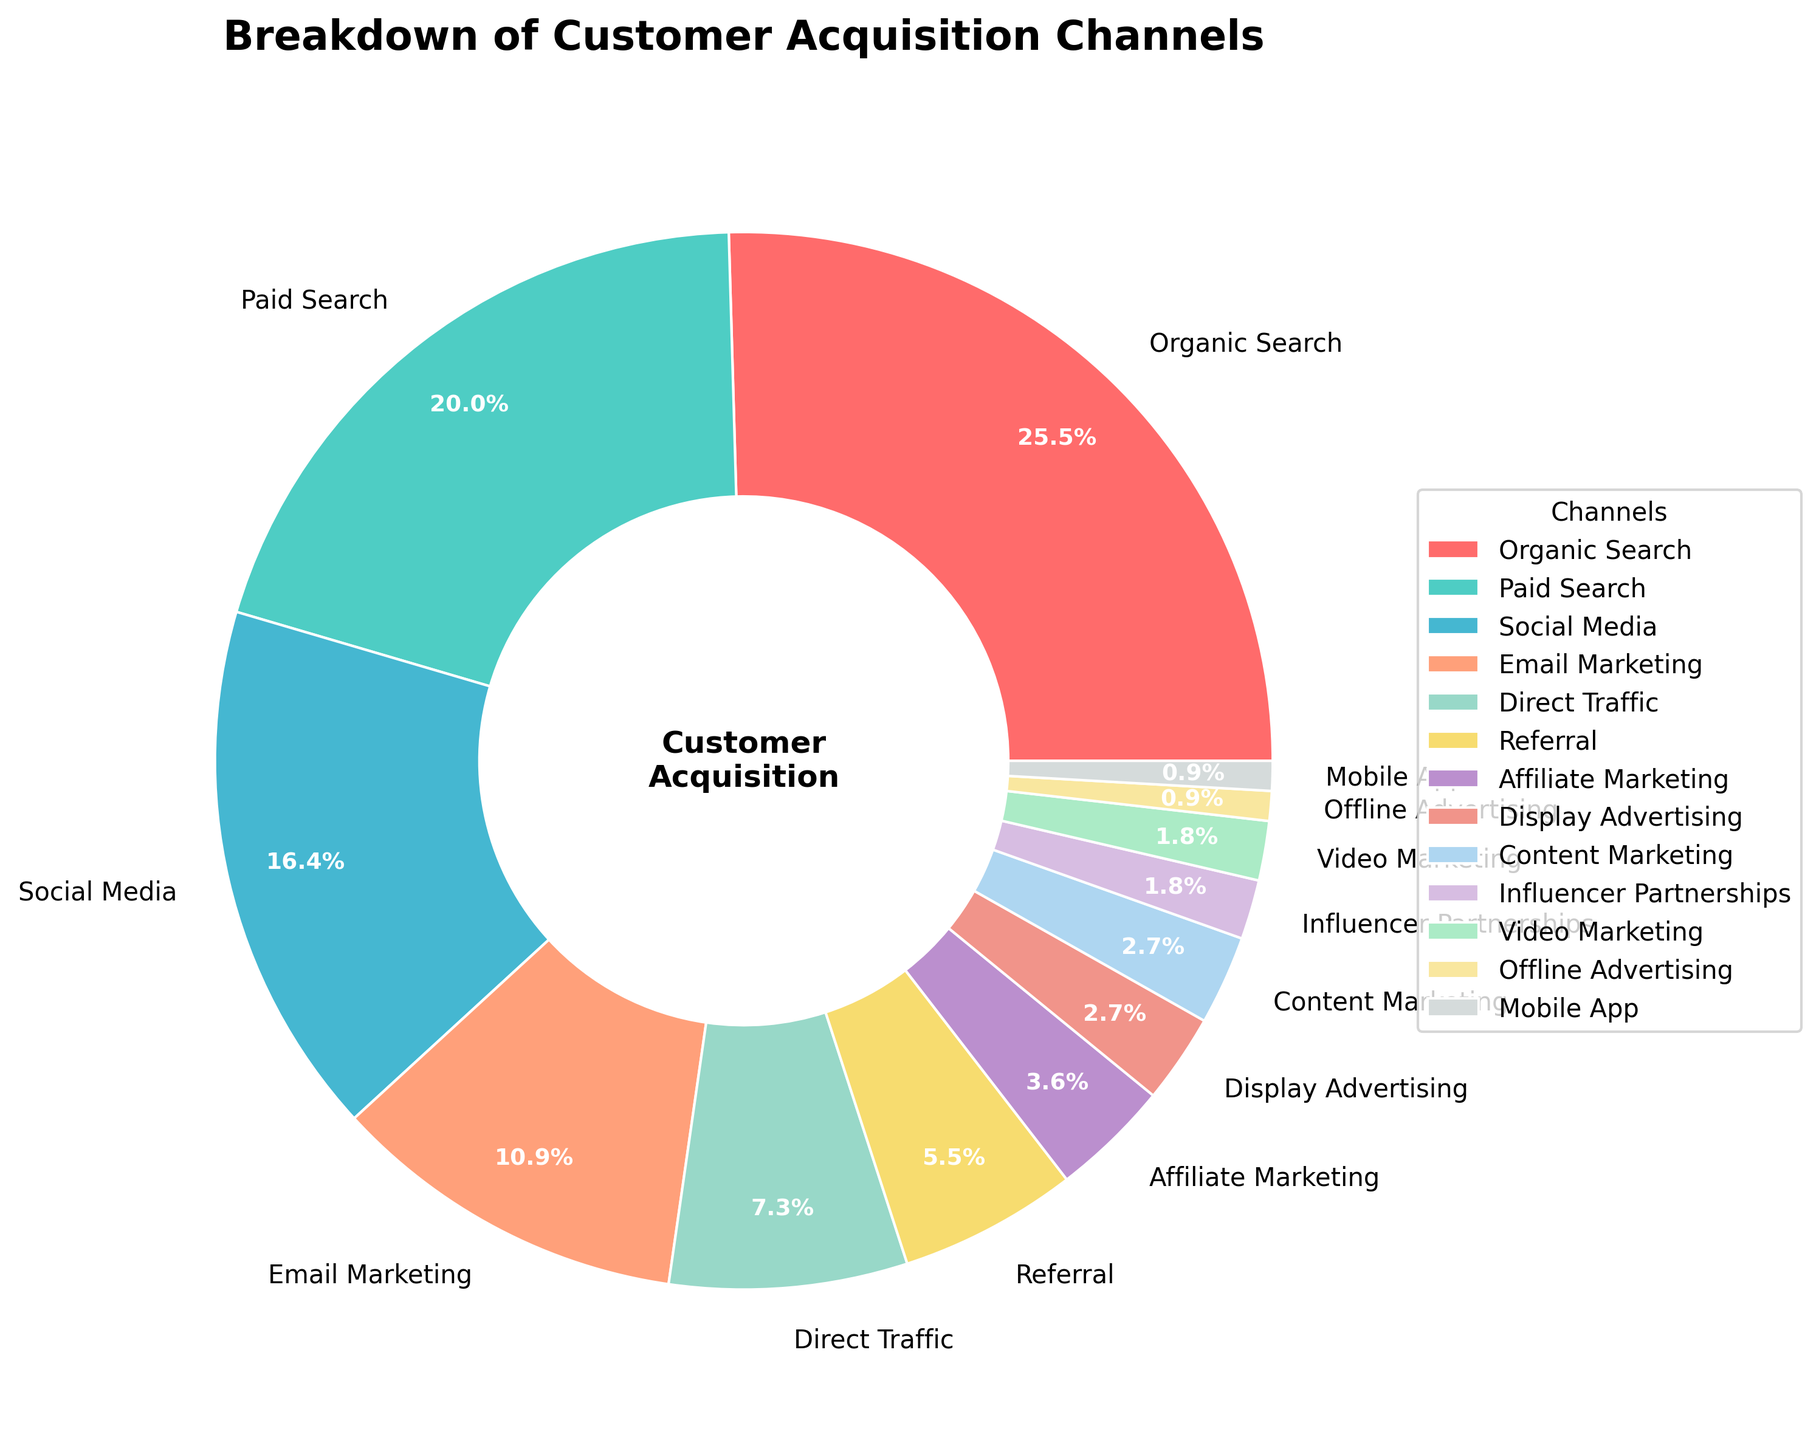Which channel has the highest percentage in customer acquisition? By examining the figure, the Organic Search segment is the largest in the pie chart. It is labeled with a percentage of 28%.
Answer: Organic Search How much more percentage does Organic Search have compared to Email Marketing? Organic Search has 28% and Email Marketing has 12%. The difference can be calculated as 28% - 12% = 16%.
Answer: 16% What is the combined percentage of Paid Search and Social Media? Paid Search is 22% and Social Media is 18%. The combined percentage is 22% + 18% = 40%.
Answer: 40% Which channel has the smallest contribution and what is its percentage? By visually inspecting the pie chart, the smallest segment belongs to Offline Advertising, labeled with a percentage of 1%.
Answer: Offline Advertising Are there any channels with equal percentages? If yes, which ones? By inspecting the figure, Content Marketing and Video Marketing both have an equal percentage of 3%.
Answer: Content Marketing and Video Marketing Which segment is represented in red color in the pie chart? By looking at the segment colored in red, it represents the Organic Search channel.
Answer: Organic Search How does the contribution of Affiliate Marketing compare to that of Display Advertising? Affiliate Marketing contributes 4%, and Display Advertising contributes 3%. Therefore, Affiliate Marketing has a greater contribution.
Answer: Greater What is the total percentage for all channels that have a contribution less than 5%? Channels with less than 5% contributions are Affiliate Marketing (4%), Display Advertising (3%), Content Marketing (3%), Influencer Partnerships (2%), Video Marketing (2%), Offline Advertising (1%), and Mobile App (1%). The total percentage is 4% + 3% + 3% + 2% + 2% + 1% + 1% = 16%.
Answer: 16% Which channel contributes more to customer acquisition, Direct Traffic or Email Marketing? Direct Traffic contributes 8%, while Email Marketing contributes 12%. Therefore, Email Marketing contributes more.
Answer: Email Marketing 